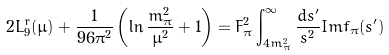Convert formula to latex. <formula><loc_0><loc_0><loc_500><loc_500>2 L _ { 9 } ^ { r } ( \mu ) + { \frac { 1 } { 9 6 \pi ^ { 2 } } } \left ( \ln { \frac { m _ { \pi } ^ { 2 } } { \mu ^ { 2 } } } + 1 \right ) = F _ { \pi } ^ { 2 } \int _ { 4 m _ { \pi } ^ { 2 } } ^ { \infty } { \frac { d s ^ { \prime } } { s ^ { 2 } } } I m f _ { \pi } ( s ^ { \prime } )</formula> 